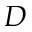Convert formula to latex. <formula><loc_0><loc_0><loc_500><loc_500>D</formula> 